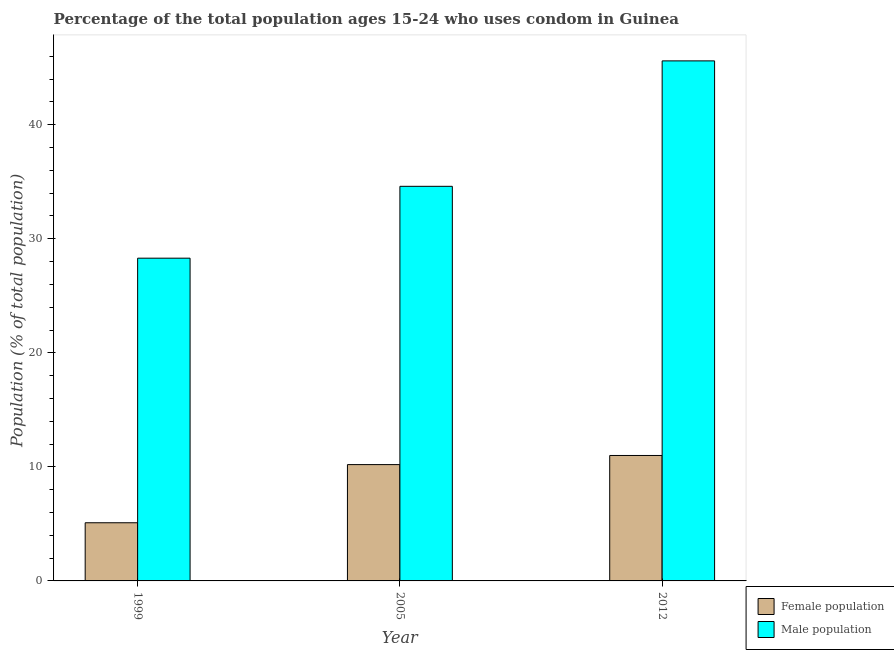How many different coloured bars are there?
Offer a very short reply. 2. How many groups of bars are there?
Ensure brevity in your answer.  3. Are the number of bars per tick equal to the number of legend labels?
Provide a short and direct response. Yes. How many bars are there on the 2nd tick from the right?
Provide a succinct answer. 2. What is the label of the 2nd group of bars from the left?
Provide a short and direct response. 2005. Across all years, what is the maximum male population?
Your answer should be very brief. 45.6. Across all years, what is the minimum male population?
Your answer should be very brief. 28.3. In which year was the male population maximum?
Offer a terse response. 2012. In which year was the male population minimum?
Your response must be concise. 1999. What is the total female population in the graph?
Keep it short and to the point. 26.3. What is the difference between the female population in 1999 and that in 2012?
Provide a short and direct response. -5.9. What is the difference between the female population in 2005 and the male population in 2012?
Make the answer very short. -0.8. What is the average male population per year?
Make the answer very short. 36.17. In the year 1999, what is the difference between the female population and male population?
Provide a succinct answer. 0. What is the ratio of the female population in 2005 to that in 2012?
Provide a succinct answer. 0.93. Is the female population in 2005 less than that in 2012?
Your answer should be compact. Yes. What is the difference between the highest and the second highest female population?
Keep it short and to the point. 0.8. What is the difference between the highest and the lowest female population?
Your answer should be compact. 5.9. Is the sum of the male population in 1999 and 2012 greater than the maximum female population across all years?
Your answer should be very brief. Yes. What does the 1st bar from the left in 2005 represents?
Your answer should be very brief. Female population. What does the 2nd bar from the right in 1999 represents?
Keep it short and to the point. Female population. How many bars are there?
Give a very brief answer. 6. Are all the bars in the graph horizontal?
Keep it short and to the point. No. What is the difference between two consecutive major ticks on the Y-axis?
Offer a terse response. 10. Does the graph contain any zero values?
Offer a very short reply. No. Does the graph contain grids?
Offer a very short reply. No. How are the legend labels stacked?
Provide a succinct answer. Vertical. What is the title of the graph?
Ensure brevity in your answer.  Percentage of the total population ages 15-24 who uses condom in Guinea. What is the label or title of the Y-axis?
Make the answer very short. Population (% of total population) . What is the Population (% of total population)  of Male population in 1999?
Provide a succinct answer. 28.3. What is the Population (% of total population)  in Male population in 2005?
Provide a short and direct response. 34.6. What is the Population (% of total population)  of Female population in 2012?
Provide a short and direct response. 11. What is the Population (% of total population)  of Male population in 2012?
Your answer should be very brief. 45.6. Across all years, what is the maximum Population (% of total population)  in Female population?
Offer a very short reply. 11. Across all years, what is the maximum Population (% of total population)  of Male population?
Your answer should be compact. 45.6. Across all years, what is the minimum Population (% of total population)  in Male population?
Give a very brief answer. 28.3. What is the total Population (% of total population)  in Female population in the graph?
Your answer should be compact. 26.3. What is the total Population (% of total population)  of Male population in the graph?
Offer a terse response. 108.5. What is the difference between the Population (% of total population)  of Male population in 1999 and that in 2005?
Your answer should be compact. -6.3. What is the difference between the Population (% of total population)  of Female population in 1999 and that in 2012?
Keep it short and to the point. -5.9. What is the difference between the Population (% of total population)  in Male population in 1999 and that in 2012?
Your answer should be compact. -17.3. What is the difference between the Population (% of total population)  of Female population in 2005 and that in 2012?
Ensure brevity in your answer.  -0.8. What is the difference between the Population (% of total population)  in Male population in 2005 and that in 2012?
Ensure brevity in your answer.  -11. What is the difference between the Population (% of total population)  of Female population in 1999 and the Population (% of total population)  of Male population in 2005?
Keep it short and to the point. -29.5. What is the difference between the Population (% of total population)  in Female population in 1999 and the Population (% of total population)  in Male population in 2012?
Offer a very short reply. -40.5. What is the difference between the Population (% of total population)  of Female population in 2005 and the Population (% of total population)  of Male population in 2012?
Give a very brief answer. -35.4. What is the average Population (% of total population)  in Female population per year?
Your answer should be very brief. 8.77. What is the average Population (% of total population)  in Male population per year?
Keep it short and to the point. 36.17. In the year 1999, what is the difference between the Population (% of total population)  of Female population and Population (% of total population)  of Male population?
Make the answer very short. -23.2. In the year 2005, what is the difference between the Population (% of total population)  in Female population and Population (% of total population)  in Male population?
Keep it short and to the point. -24.4. In the year 2012, what is the difference between the Population (% of total population)  in Female population and Population (% of total population)  in Male population?
Your answer should be compact. -34.6. What is the ratio of the Population (% of total population)  of Male population in 1999 to that in 2005?
Your response must be concise. 0.82. What is the ratio of the Population (% of total population)  in Female population in 1999 to that in 2012?
Keep it short and to the point. 0.46. What is the ratio of the Population (% of total population)  of Male population in 1999 to that in 2012?
Your response must be concise. 0.62. What is the ratio of the Population (% of total population)  in Female population in 2005 to that in 2012?
Your answer should be very brief. 0.93. What is the ratio of the Population (% of total population)  in Male population in 2005 to that in 2012?
Your answer should be compact. 0.76. What is the difference between the highest and the second highest Population (% of total population)  of Female population?
Offer a terse response. 0.8. What is the difference between the highest and the second highest Population (% of total population)  in Male population?
Offer a very short reply. 11. What is the difference between the highest and the lowest Population (% of total population)  in Female population?
Offer a terse response. 5.9. 